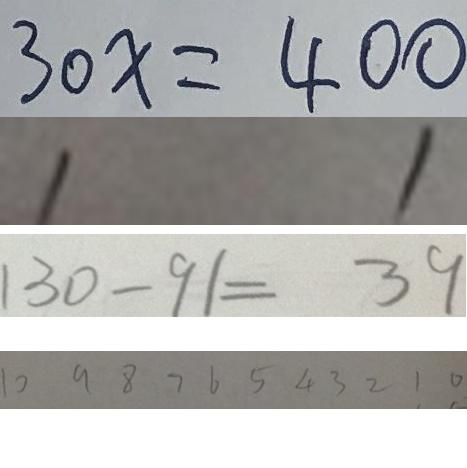Convert formula to latex. <formula><loc_0><loc_0><loc_500><loc_500>3 0 x = 4 0 0 
 1 1 
 1 3 0 - 9 1 = 3 9 
 1 0 9 8 7 6 5 4 3 2 1 0</formula> 